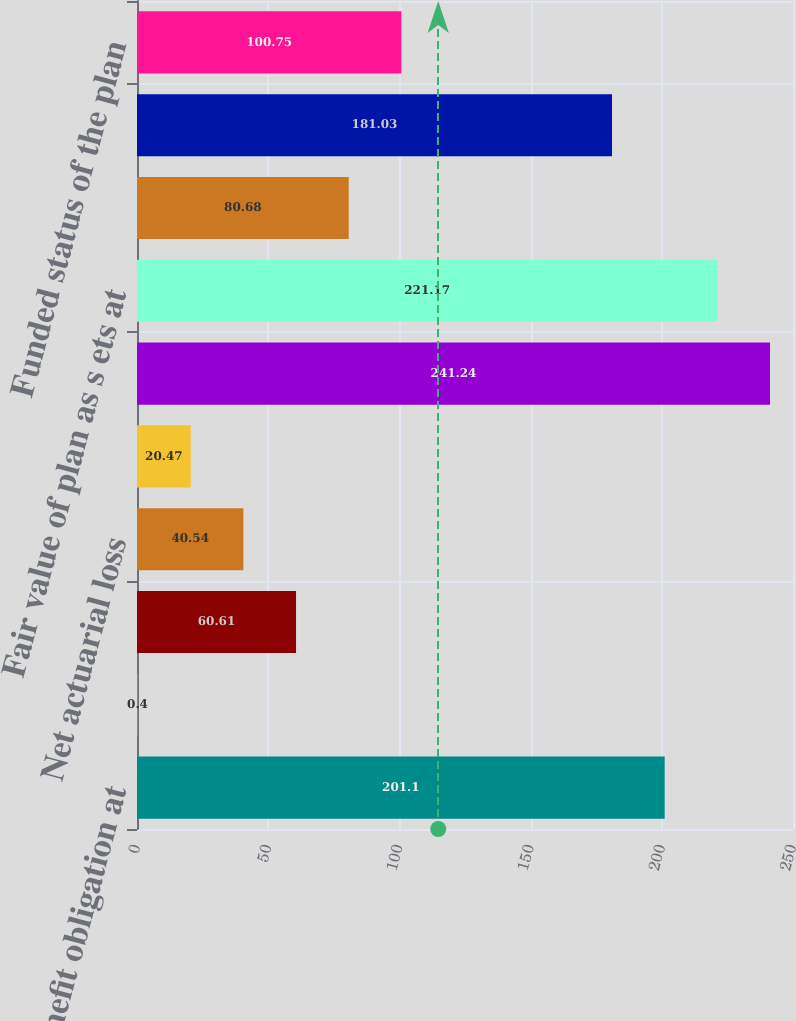<chart> <loc_0><loc_0><loc_500><loc_500><bar_chart><fcel>Benefit obligation at<fcel>Service cost<fcel>Interest cost<fcel>Net actuarial loss<fcel>Benefits paid<fcel>Benefit obligation at end of<fcel>Fair value of plan as s ets at<fcel>Actual return on plan assets<fcel>Fair value of plan assets at<fcel>Funded status of the plan<nl><fcel>201.1<fcel>0.4<fcel>60.61<fcel>40.54<fcel>20.47<fcel>241.24<fcel>221.17<fcel>80.68<fcel>181.03<fcel>100.75<nl></chart> 